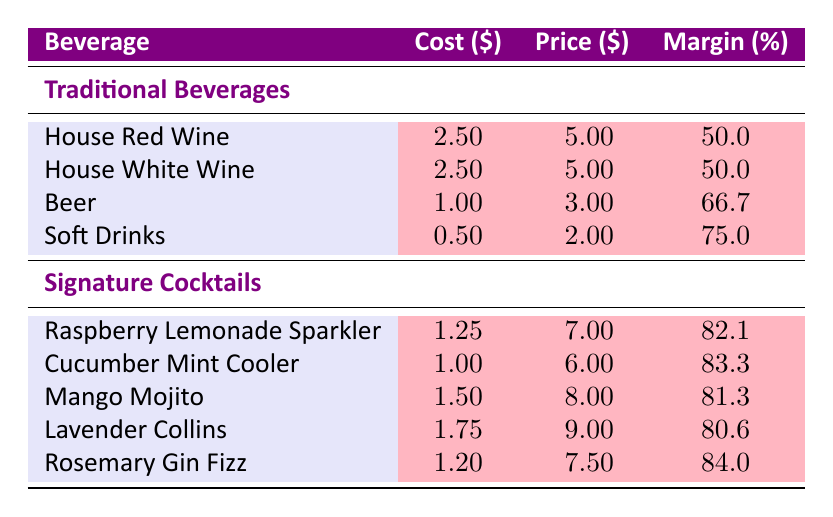What is the profit margin of the House White Wine? The table lists the profit margin for the House White Wine as 50.0%.
Answer: 50.0% Which signature cocktail has the highest profit margin? Looking through the profit margins of the signature cocktails, the Rosemary Gin Fizz has the highest profit margin at 84.0%.
Answer: 84.0% What is the cost per serving of the Raspberry Lemonade Sparkler? The cost per serving for the Raspberry Lemonade Sparkler is listed as 1.25.
Answer: 1.25 How much more does the Soft Drink's profit margin exceed that of House Red Wine? The profit margin for Soft Drinks is 75.0%, and for House Red Wine it is 50.0%. The difference is 75.0 - 50.0 = 25.0.
Answer: 25.0 Is the profit margin of the Cucumber Mint Cooler greater than the Soft Drinks? The profit margin of the Cucumber Mint Cooler is 83.3%, which is greater than the Soft Drinks' profit margin of 75.0%.
Answer: Yes What is the average profit margin for the Traditional Beverages? The profit margins for the Traditional Beverages are 50.0, 50.0, 66.7, and 75.0. Adding these together gives 242.0, and dividing by the number of beverages (4) gives an average of 242.0 / 4 = 60.5.
Answer: 60.5 How does the profit margin of the Mango Mojito compare to that of the Beer? The profit margin of the Mango Mojito is 81.3% while the Beer is 66.7%. The Mango Mojito's profit margin exceeds that of the Beer by 81.3 - 66.7 = 14.6.
Answer: 14.6 What is the total profit margin of all signature cocktails combined? The profit margins of the signature cocktails are 82.1, 83.3, 81.3, 80.6, and 84.0. Summing these up gives 411.3, which when divided by the number of cocktails (5) gives an average profit margin of 411.3 / 5 = 82.26.
Answer: 82.26 